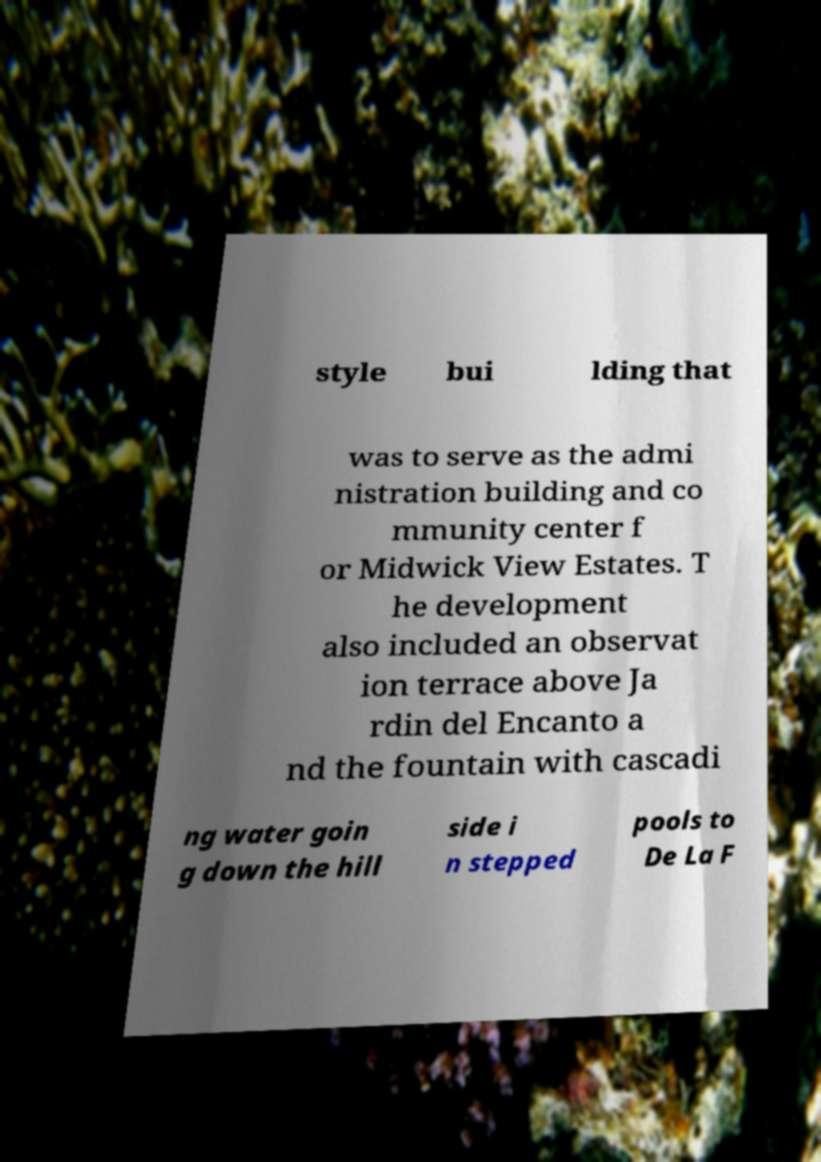For documentation purposes, I need the text within this image transcribed. Could you provide that? style bui lding that was to serve as the admi nistration building and co mmunity center f or Midwick View Estates. T he development also included an observat ion terrace above Ja rdin del Encanto a nd the fountain with cascadi ng water goin g down the hill side i n stepped pools to De La F 